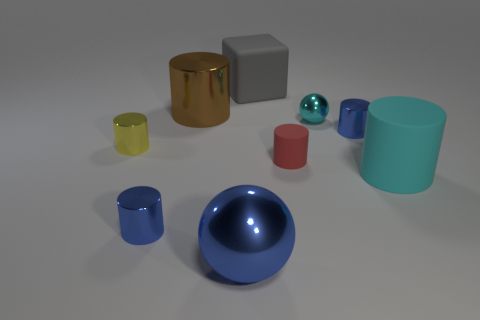Does the shiny object that is behind the cyan shiny sphere have the same size as the rubber block? The shiny object located behind the cyan sphere appears to have a comparable size to the grey rubber block in the foreground when viewed from the current angle. However, without precise measurements, we cannot conclude definitively that they are the exact same size, as perspective can affect visual judgment of sizes. 